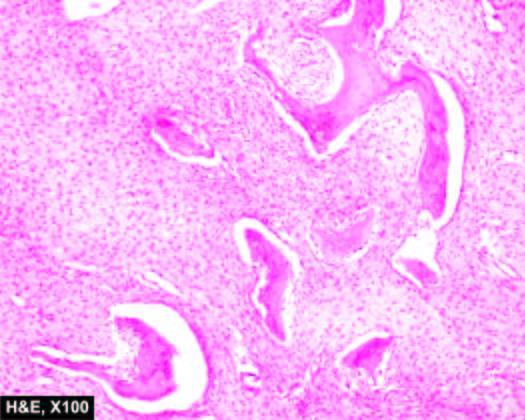what do the bony trabeculae have?
Answer the question using a single word or phrase. Fish-hook appearance surrounded by fibrous tissue 